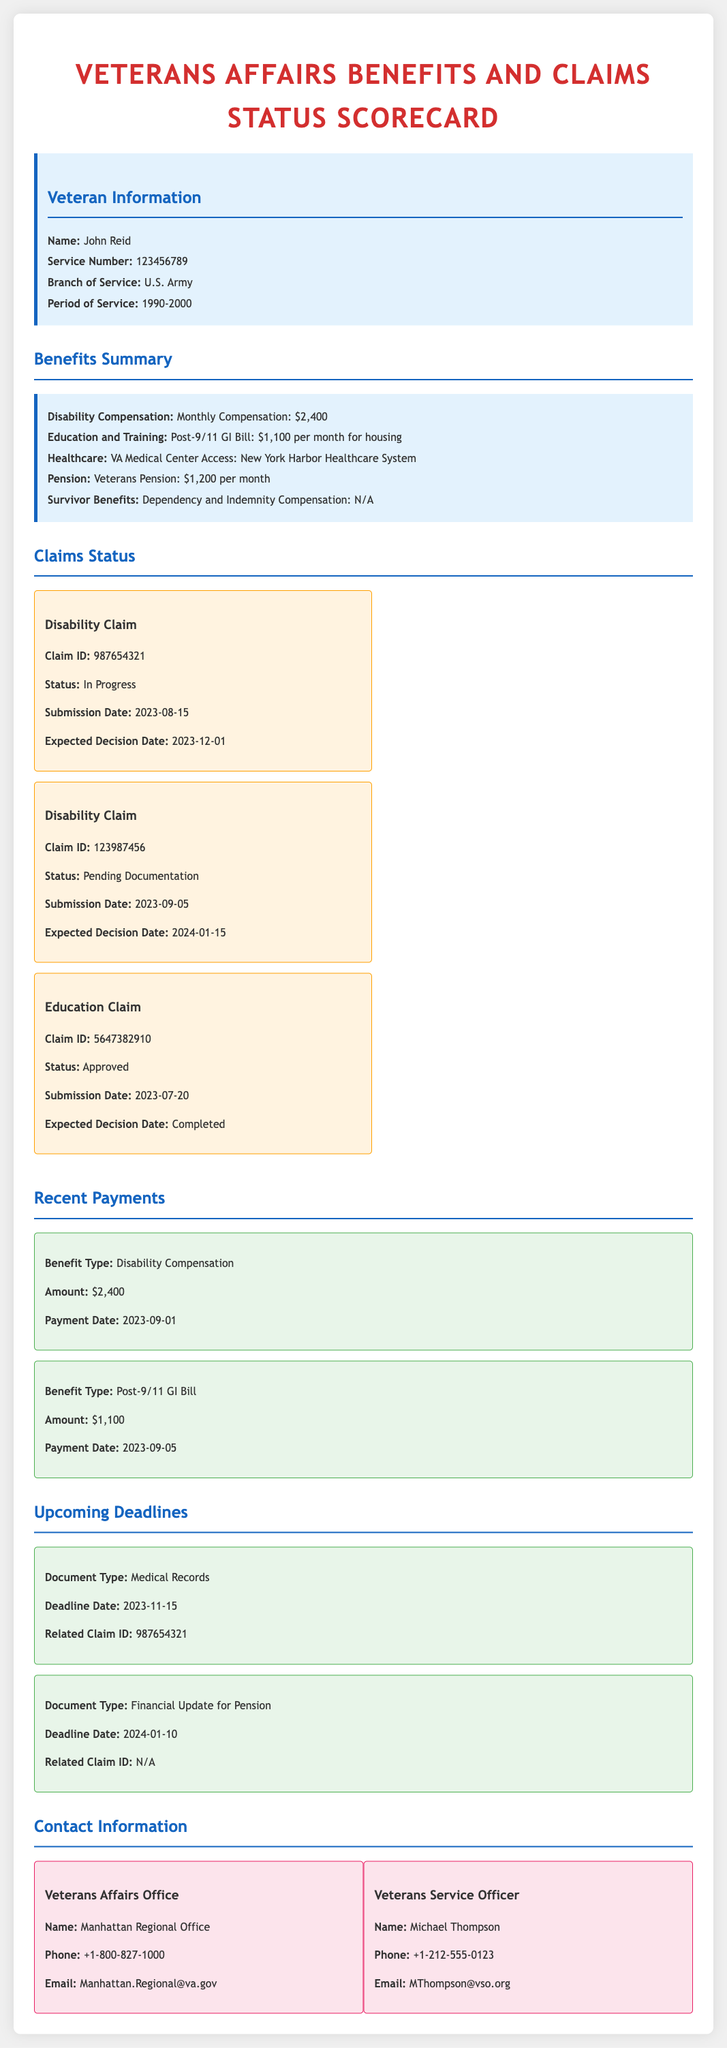what is the veteran's name? The veteran's name is listed in the Veteran Information section of the document as John Reid.
Answer: John Reid what is the monthly amount for Disability Compensation? The document states the monthly amount for Disability Compensation under Benefits Summary, which is $2,400.
Answer: $2,400 what is the status of Claim ID 987654321? The status of Claim ID 987654321 is found in the Claims Status section, indicating it is "In Progress".
Answer: In Progress what is the expected decision date for Claim ID 123987456? The expected decision date for Claim ID 123987456 is specified in the Claims Status section as 2024-01-15.
Answer: 2024-01-15 what is the payment date for the Post-9/11 GI Bill? The payment date for the Post-9/11 GI Bill is found in the Recent Payments section, which is 2023-09-05.
Answer: 2023-09-05 what document type has a deadline of November 15, 2023? The document type with a deadline of November 15, 2023, is mentioned under Upcoming Deadlines as "Medical Records".
Answer: Medical Records how much is the monthly amount for the Veterans Pension? The document outlines the monthly amount for the Veterans Pension in the Benefits Summary as $1,200.
Answer: $1,200 who is the Veterans Service Officer? The document identifies the Veterans Service Officer's name in the Contact Information section as Michael Thompson.
Answer: Michael Thompson 